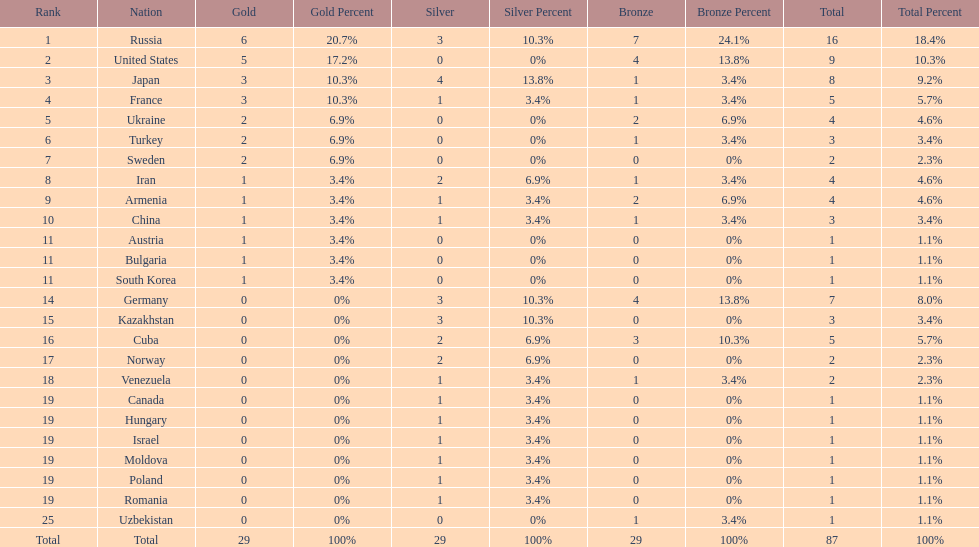What is the total amount of nations with more than 5 bronze medals? 1. 